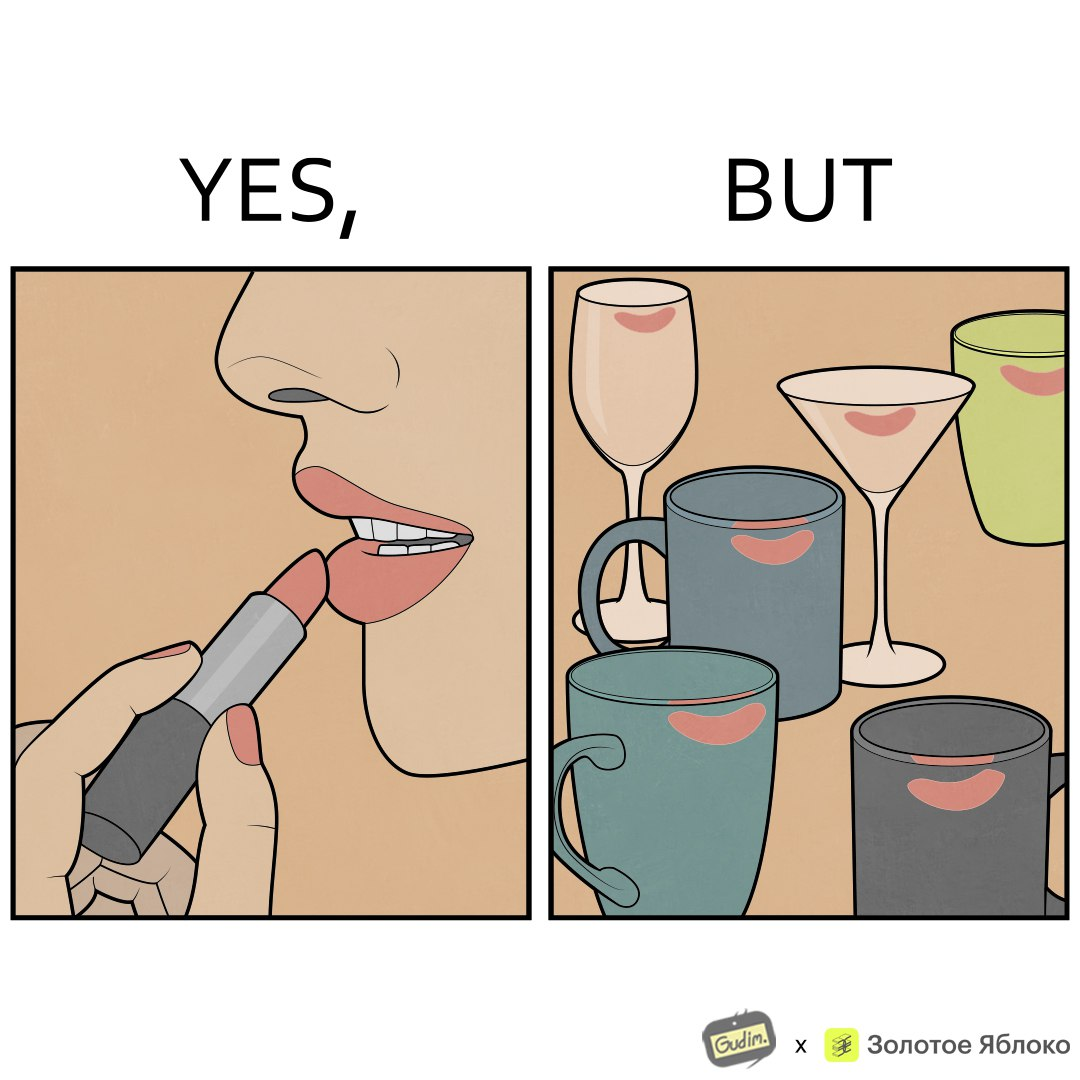Describe the content of this image. The image is ironic, because the left image suggest that a person applies lipsticks on their lips to make their lips look attractive or to keep them hydrated but on the contrary it gets sticked to the glasses or mugs and gets wasted 